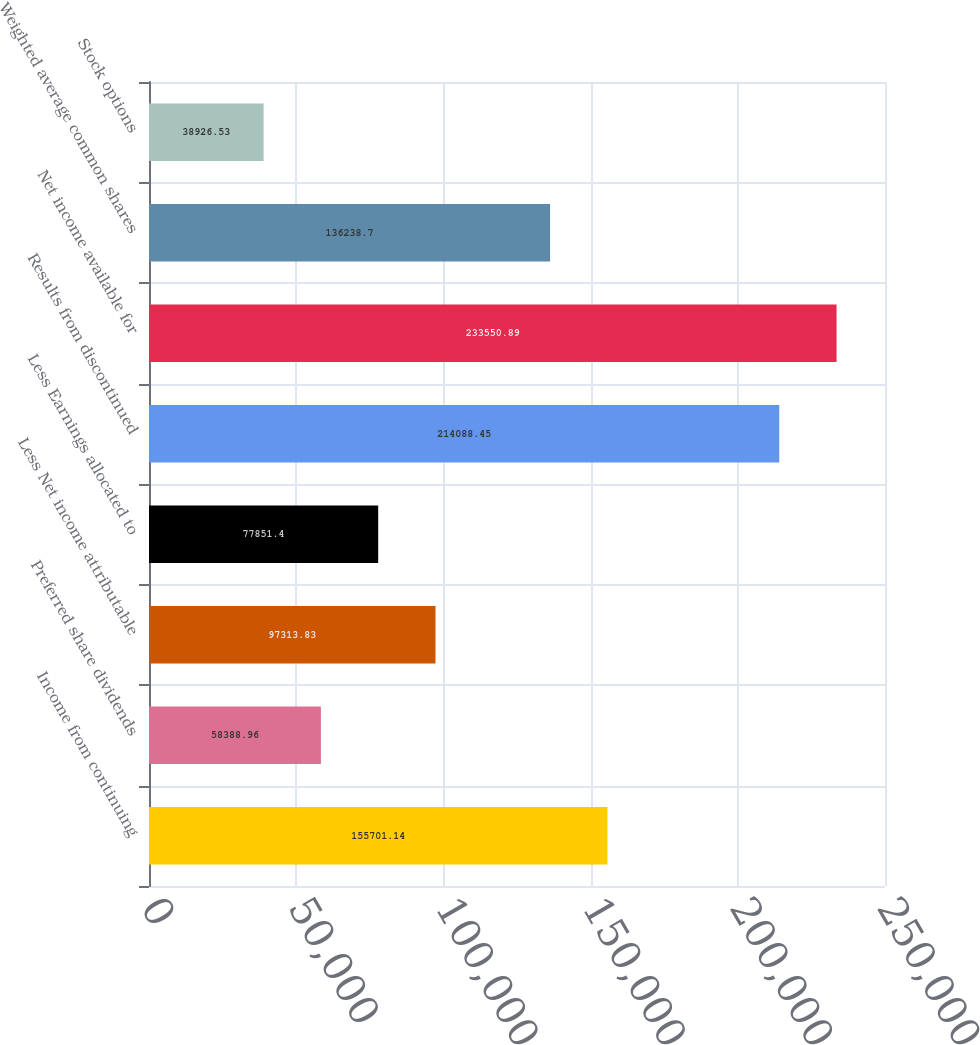Convert chart to OTSL. <chart><loc_0><loc_0><loc_500><loc_500><bar_chart><fcel>Income from continuing<fcel>Preferred share dividends<fcel>Less Net income attributable<fcel>Less Earnings allocated to<fcel>Results from discontinued<fcel>Net income available for<fcel>Weighted average common shares<fcel>Stock options<nl><fcel>155701<fcel>58389<fcel>97313.8<fcel>77851.4<fcel>214088<fcel>233551<fcel>136239<fcel>38926.5<nl></chart> 